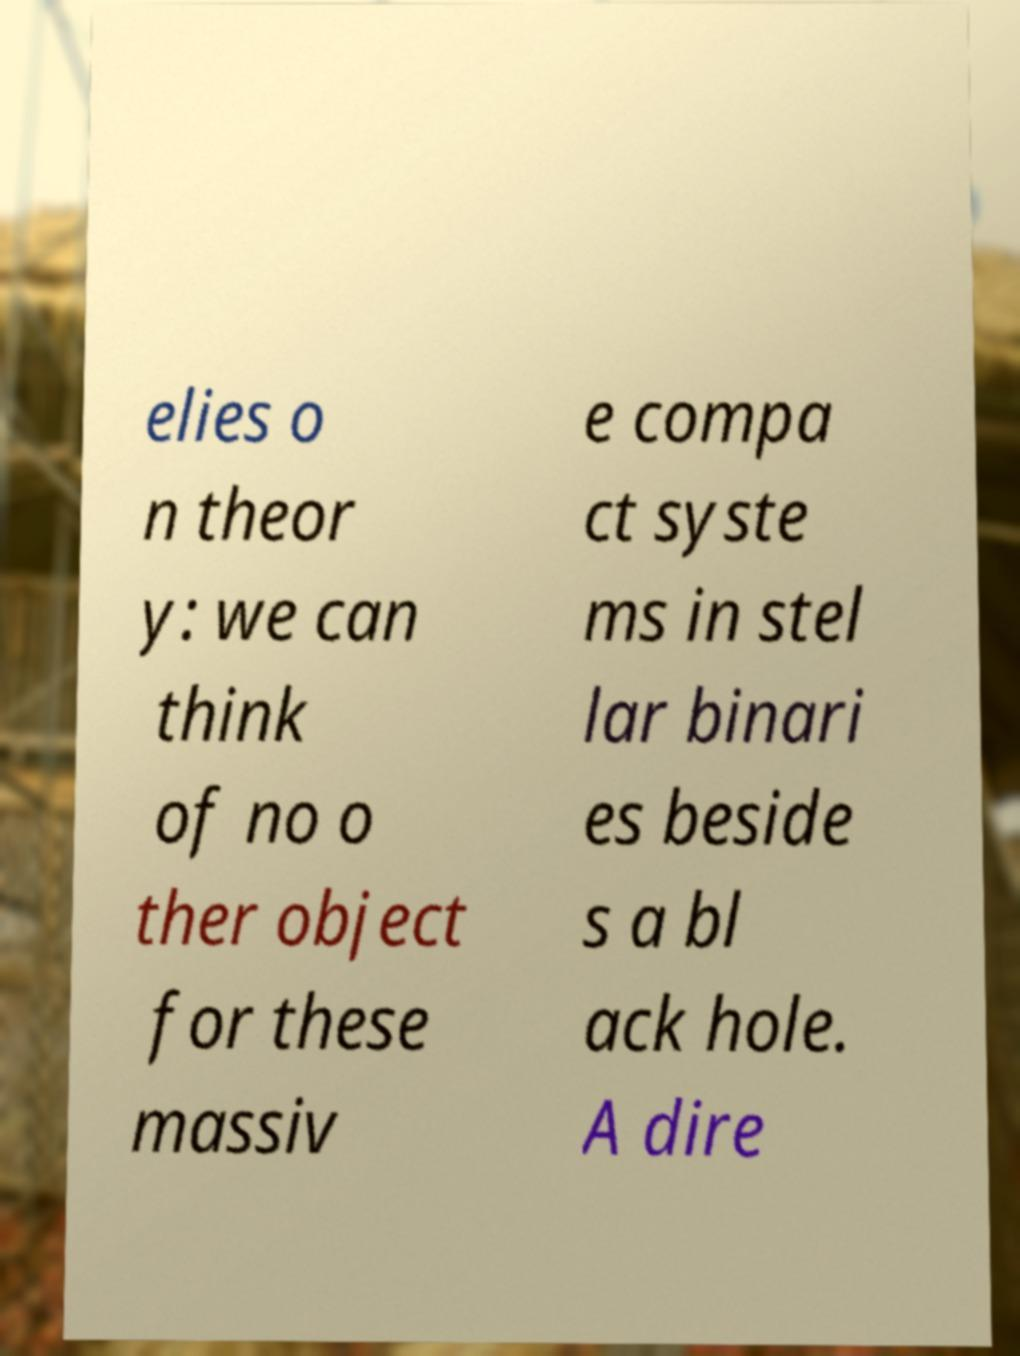For documentation purposes, I need the text within this image transcribed. Could you provide that? elies o n theor y: we can think of no o ther object for these massiv e compa ct syste ms in stel lar binari es beside s a bl ack hole. A dire 